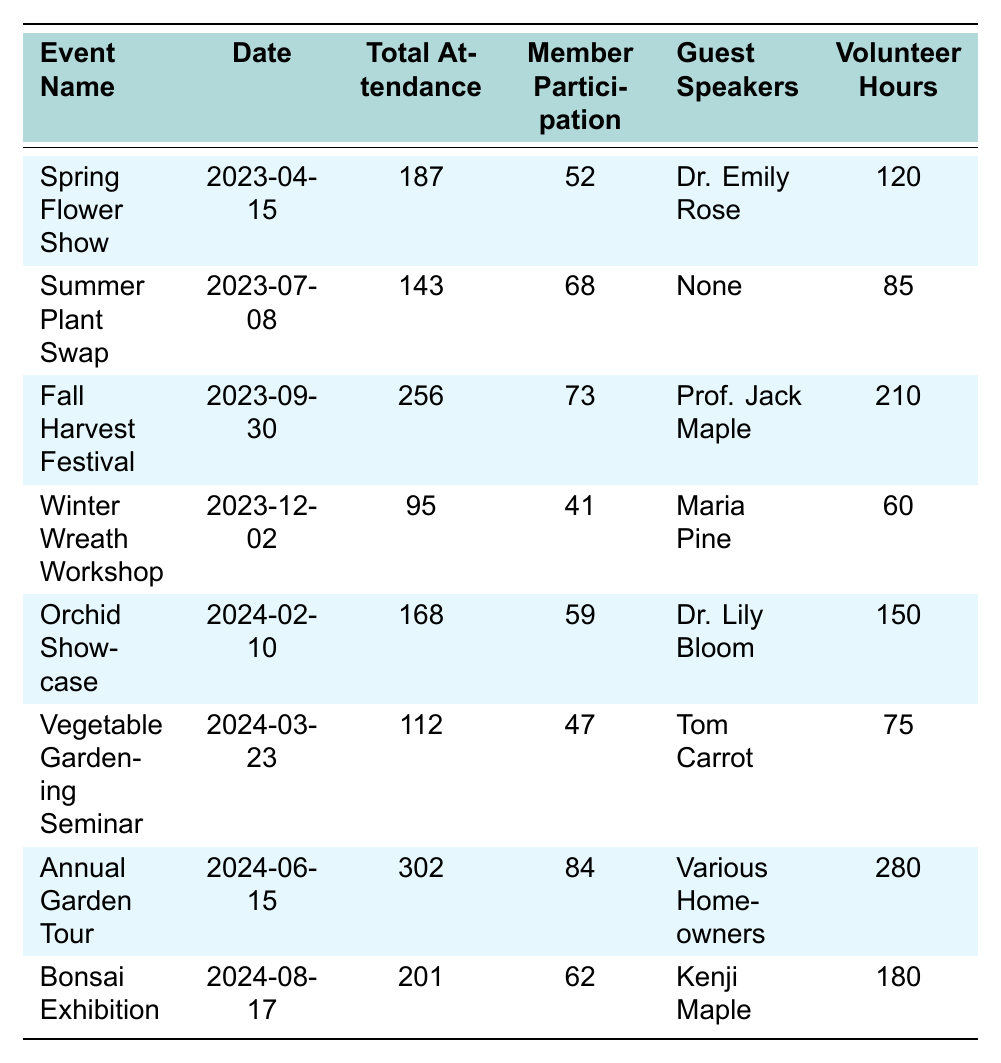What was the total attendance for the Fall Harvest Festival? Referring to the table, the total attendance listed for the Fall Harvest Festival is 256.
Answer: 256 How many volunteer hours were recorded for the Annual Garden Tour? The table indicates that the Annual Garden Tour had 280 volunteer hours.
Answer: 280 What is the member participation rate for the Summer Plant Swap? The member participation for the Summer Plant Swap is reported as 68.
Answer: 68 Which event had the highest total attendance? By examining the attendance figures, the Annual Garden Tour has the highest total attendance at 302.
Answer: Annual Garden Tour Did the Winter Wreath Workshop have more member participation than the Vegetable Gardening Seminar? The Winter Wreath Workshop had 41 members participating, while the Vegetable Gardening Seminar had 47; therefore, it did not have more.
Answer: No What is the average member participation for all events listed in the table? First, sum the member participation values: 52 + 68 + 73 + 41 + 59 + 47 + 84 + 62 = 486. Then, divide by the number of events (8): 486 / 8 = 60.75.
Answer: 60.75 Which event had a guest speaker, and what is the name of that speaker? The events that had guest speakers are the Spring Flower Show (Dr. Emily Rose), Fall Harvest Festival (Prof. Jack Maple), Orchid Showcase (Dr. Lily Bloom), Vegetable Gardening Seminar (Tom Carrot), Annual Garden Tour (Various Homeowners), and Bonsai Exhibition (Kenji Maple).
Answer: Multiple events had guest speakers How many more members participated in the Annual Garden Tour compared to the Winter Wreath Workshop? The Annual Garden Tour had 84 members, and the Winter Wreath Workshop had 41 members. The difference is 84 - 41 = 43.
Answer: 43 Was the total attendance for the Spring Flower Show greater than the Winter Wreath Workshop? The Spring Flower Show had total attendance of 187, while the Winter Wreath Workshop had 95. Since 187 > 95, the statement is true.
Answer: Yes What percentage of attendees were members at the Fall Harvest Festival? To find the percentage, divide member participation (73) by total attendance (256) and multiply by 100: (73 / 256) * 100 ≈ 28.5%.
Answer: 28.5% 